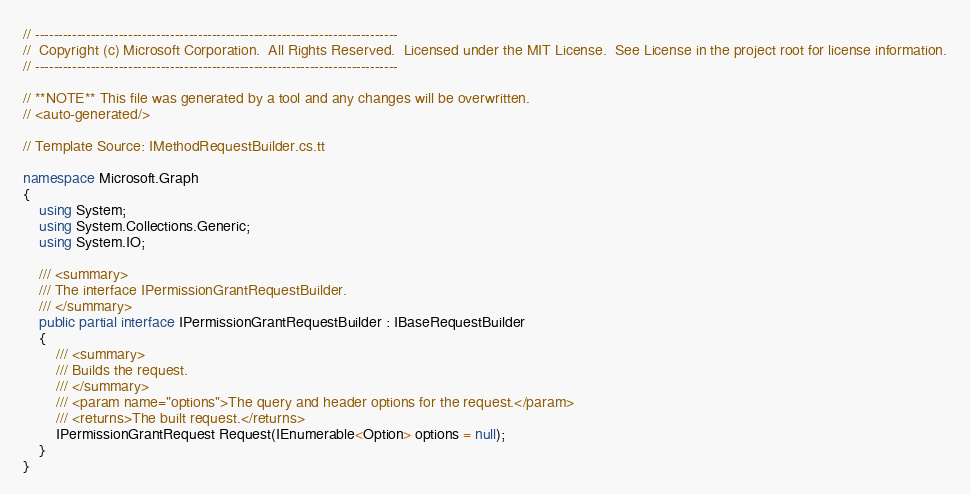Convert code to text. <code><loc_0><loc_0><loc_500><loc_500><_C#_>// ------------------------------------------------------------------------------
//  Copyright (c) Microsoft Corporation.  All Rights Reserved.  Licensed under the MIT License.  See License in the project root for license information.
// ------------------------------------------------------------------------------

// **NOTE** This file was generated by a tool and any changes will be overwritten.
// <auto-generated/>

// Template Source: IMethodRequestBuilder.cs.tt

namespace Microsoft.Graph
{
    using System;
    using System.Collections.Generic;
    using System.IO;

    /// <summary>
    /// The interface IPermissionGrantRequestBuilder.
    /// </summary>
    public partial interface IPermissionGrantRequestBuilder : IBaseRequestBuilder
    {
        /// <summary>
        /// Builds the request.
        /// </summary>
        /// <param name="options">The query and header options for the request.</param>
        /// <returns>The built request.</returns>
        IPermissionGrantRequest Request(IEnumerable<Option> options = null);
    }
}
</code> 